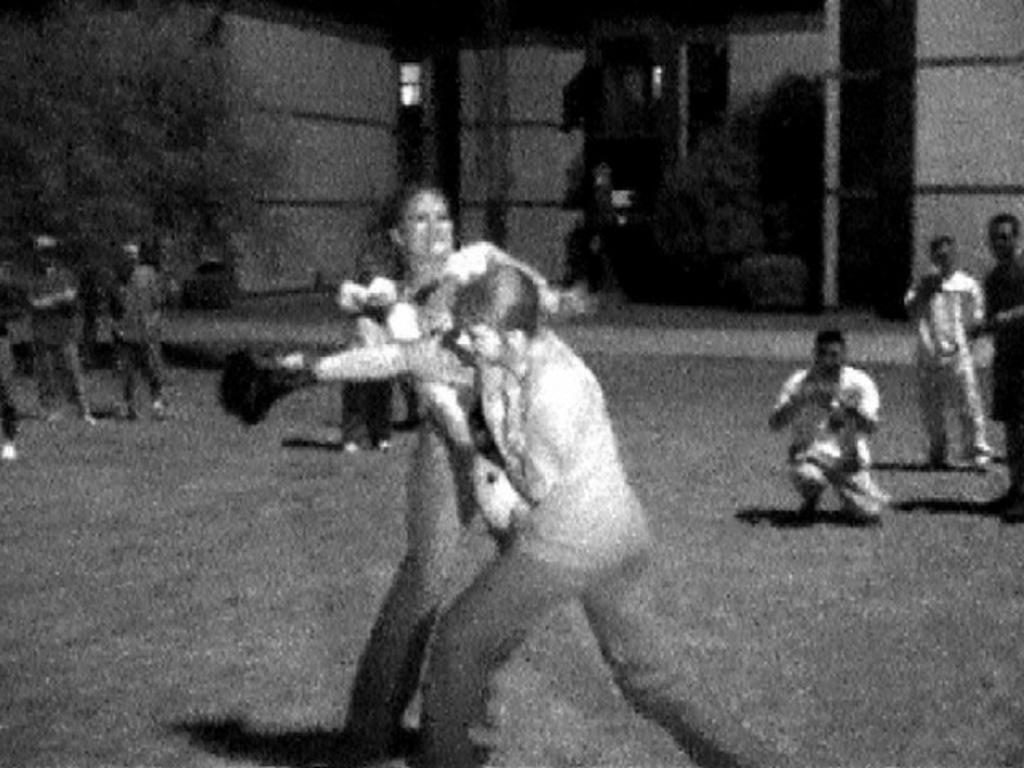What is the color scheme of the image? The image is black and white. What activity is being performed by the persons in the center of the image? The persons in the center of the image are performing boxing. What can be seen in the background of the image? There is a building in the background of the image. What are the people in the background doing? The people in the background are watching the boxing. What type of flowers can be seen growing near the seashore in the image? There is no seashore or flowers present in the image; it features a black and white image of a boxing match with a building in the background. 